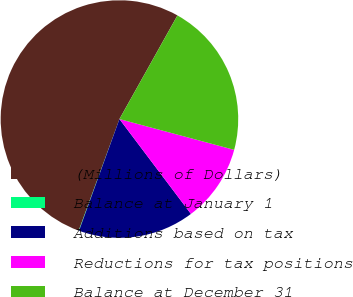<chart> <loc_0><loc_0><loc_500><loc_500><pie_chart><fcel>(Millions of Dollars)<fcel>Balance at January 1<fcel>Additions based on tax<fcel>Reductions for tax positions<fcel>Balance at December 31<nl><fcel>52.55%<fcel>0.05%<fcel>15.8%<fcel>10.55%<fcel>21.05%<nl></chart> 